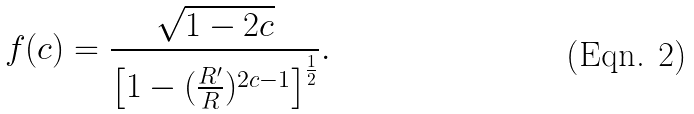Convert formula to latex. <formula><loc_0><loc_0><loc_500><loc_500>f ( c ) = \frac { \sqrt { 1 - 2 c } } { \left [ 1 - ( \frac { R ^ { \prime } } { R } ) ^ { 2 c - 1 } \right ] ^ { \frac { 1 } { 2 } } } .</formula> 